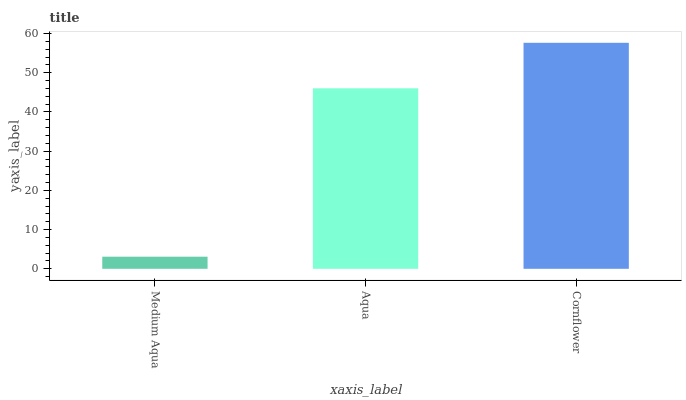Is Medium Aqua the minimum?
Answer yes or no. Yes. Is Cornflower the maximum?
Answer yes or no. Yes. Is Aqua the minimum?
Answer yes or no. No. Is Aqua the maximum?
Answer yes or no. No. Is Aqua greater than Medium Aqua?
Answer yes or no. Yes. Is Medium Aqua less than Aqua?
Answer yes or no. Yes. Is Medium Aqua greater than Aqua?
Answer yes or no. No. Is Aqua less than Medium Aqua?
Answer yes or no. No. Is Aqua the high median?
Answer yes or no. Yes. Is Aqua the low median?
Answer yes or no. Yes. Is Medium Aqua the high median?
Answer yes or no. No. Is Medium Aqua the low median?
Answer yes or no. No. 